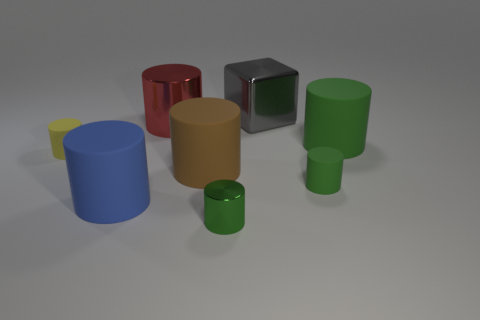Subtract all tiny green matte cylinders. How many cylinders are left? 6 Add 1 red objects. How many objects exist? 9 Subtract all brown cylinders. How many cylinders are left? 6 Subtract all blocks. How many objects are left? 7 Subtract 1 cylinders. How many cylinders are left? 6 Subtract all green balls. How many brown cylinders are left? 1 Subtract all small gray matte blocks. Subtract all shiny cylinders. How many objects are left? 6 Add 7 big cubes. How many big cubes are left? 8 Add 3 large brown rubber objects. How many large brown rubber objects exist? 4 Subtract 0 green spheres. How many objects are left? 8 